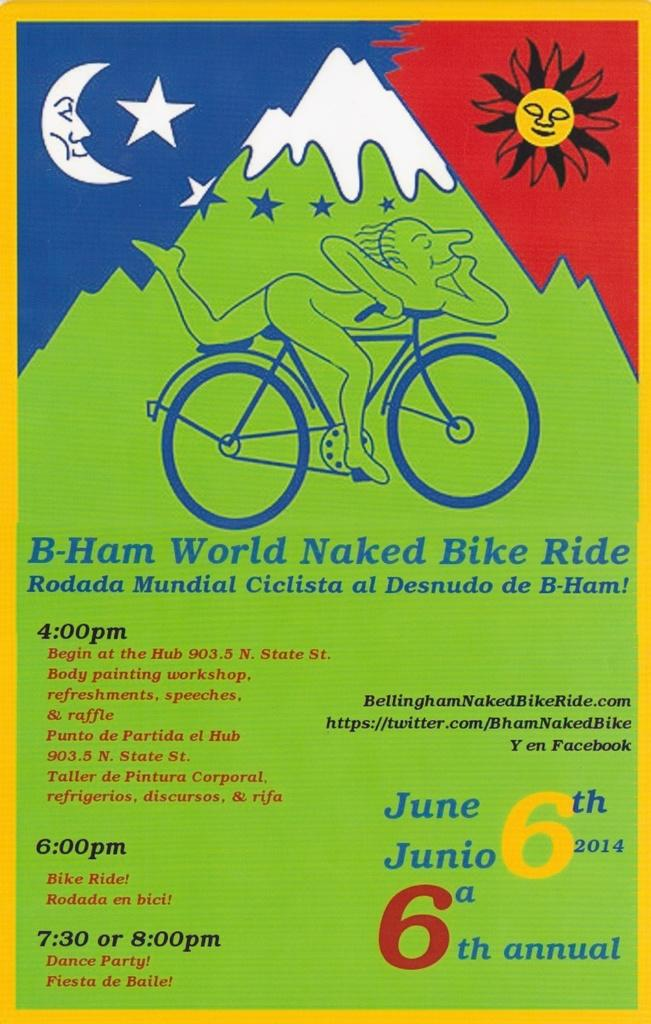<image>
Write a terse but informative summary of the picture. A poster with an illustration of a person riding a bicycle has the words B-Ham World Naked Bike Ride below the illustration. 